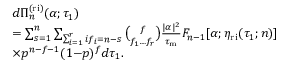Convert formula to latex. <formula><loc_0><loc_0><loc_500><loc_500>\begin{array} { r l } & { d \Pi _ { n } ^ { ( r i ) } ( \alpha ; \tau _ { 1 } ) } \\ & { = \sum _ { s = 1 } ^ { n } \sum _ { \sum _ { i = 1 } ^ { r } i f _ { i } = n - s } \binom { f } { f _ { 1 } \dots f _ { r } } \frac { | \alpha | ^ { 2 } } { \tau _ { m } } F _ { n - 1 } [ \alpha ; \eta _ { r i } ( \tau _ { 1 } ; n ) ] } \\ & { \times p ^ { n - f - 1 } ( 1 { - } p ) ^ { f } d \tau _ { 1 } . } \end{array}</formula> 